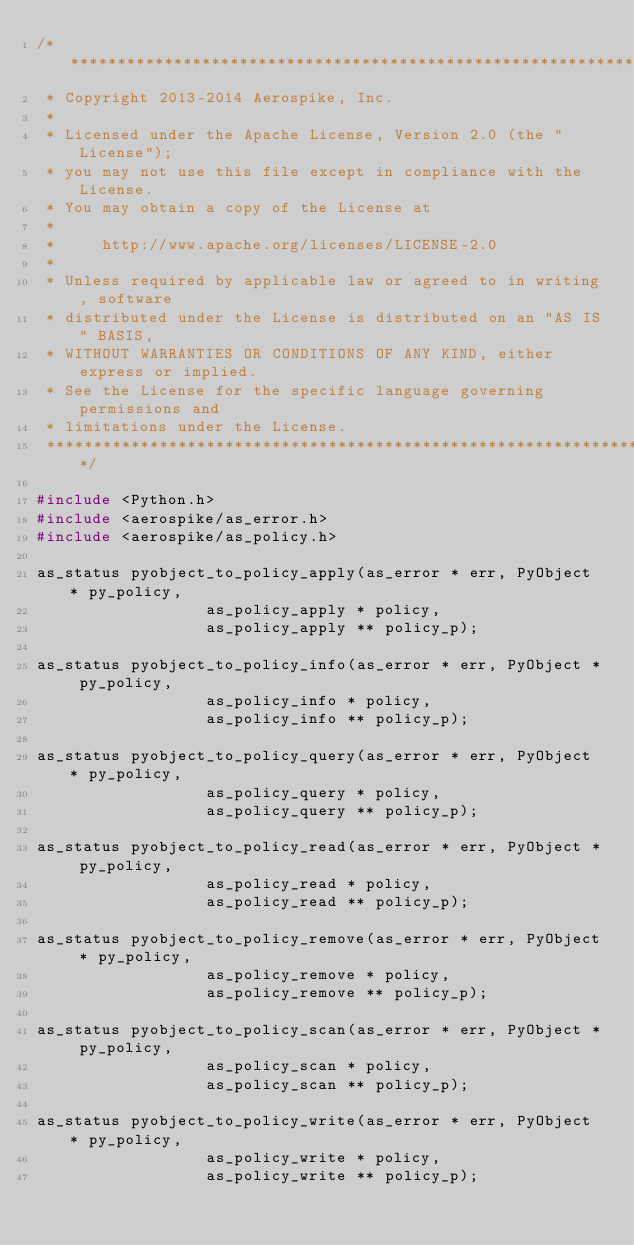Convert code to text. <code><loc_0><loc_0><loc_500><loc_500><_C_>/*******************************************************************************
 * Copyright 2013-2014 Aerospike, Inc.
 *
 * Licensed under the Apache License, Version 2.0 (the "License");
 * you may not use this file except in compliance with the License.
 * You may obtain a copy of the License at
 *
 *     http://www.apache.org/licenses/LICENSE-2.0
 *
 * Unless required by applicable law or agreed to in writing, software
 * distributed under the License is distributed on an "AS IS" BASIS,
 * WITHOUT WARRANTIES OR CONDITIONS OF ANY KIND, either express or implied.
 * See the License for the specific language governing permissions and
 * limitations under the License.
 ******************************************************************************/

#include <Python.h>
#include <aerospike/as_error.h>
#include <aerospike/as_policy.h>

as_status pyobject_to_policy_apply(as_error * err, PyObject * py_policy,
									as_policy_apply * policy,
									as_policy_apply ** policy_p);

as_status pyobject_to_policy_info(as_error * err, PyObject * py_policy,
									as_policy_info * policy,
									as_policy_info ** policy_p);

as_status pyobject_to_policy_query(as_error * err, PyObject * py_policy,
									as_policy_query * policy,
									as_policy_query ** policy_p);

as_status pyobject_to_policy_read(as_error * err, PyObject * py_policy,
									as_policy_read * policy,
									as_policy_read ** policy_p);

as_status pyobject_to_policy_remove(as_error * err, PyObject * py_policy,
									as_policy_remove * policy,
									as_policy_remove ** policy_p);

as_status pyobject_to_policy_scan(as_error * err, PyObject * py_policy,
									as_policy_scan * policy,
									as_policy_scan ** policy_p);

as_status pyobject_to_policy_write(as_error * err, PyObject * py_policy,
									as_policy_write * policy,
									as_policy_write ** policy_p);
</code> 